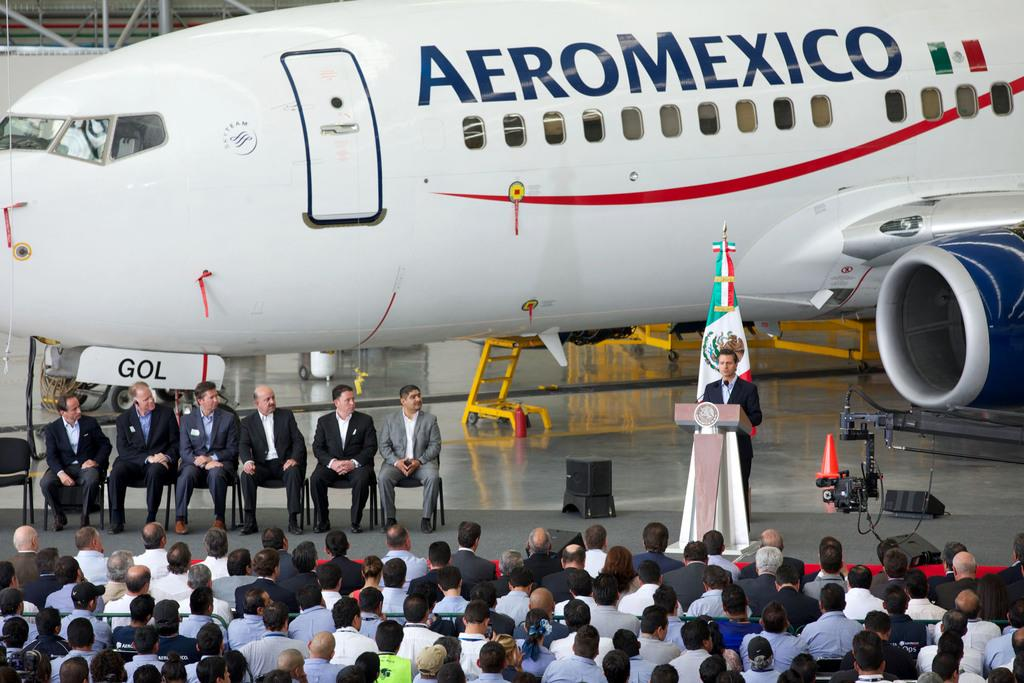<image>
Present a compact description of the photo's key features. A man is giving a speech in front of an AeroMexico airplane. 